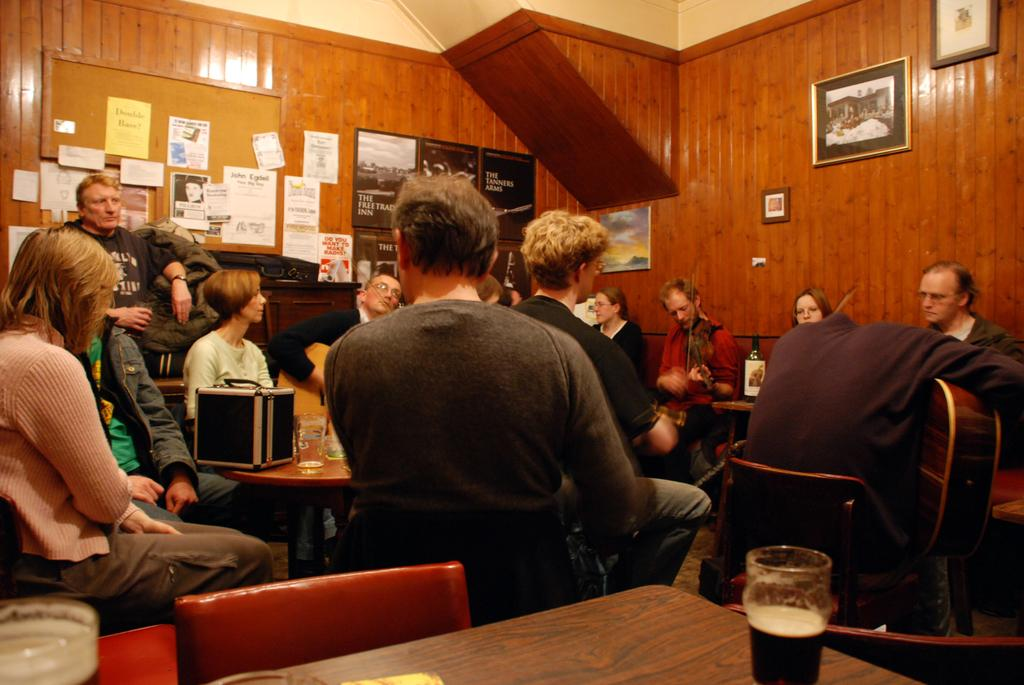How many people are in the image? There is a group of people in the image. What are the people doing in the image? The people are sitting on chairs. What is on the table in the image? There is a glass on the table. What can be seen in the background of the image? In the background, there are posters, a photo frame, and a cupboard. What type of light is being used to illuminate the invention in the image? There is no light or invention present in the image. 